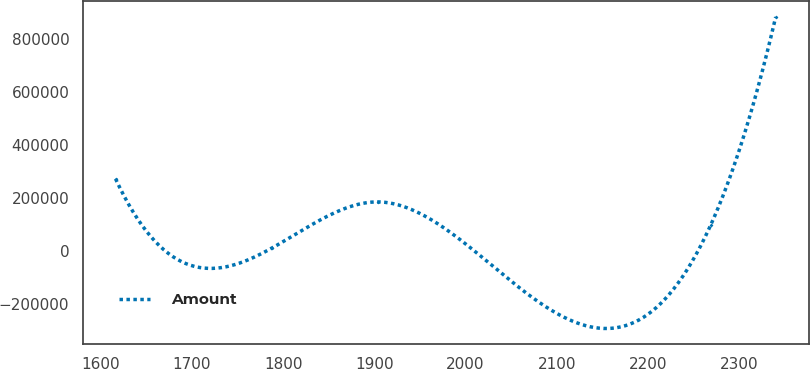Convert chart to OTSL. <chart><loc_0><loc_0><loc_500><loc_500><line_chart><ecel><fcel>Amount<nl><fcel>1616.24<fcel>272656<nl><fcel>1787.55<fcel>11758.5<nl><fcel>1903.82<fcel>185690<nl><fcel>2268.88<fcel>98724.5<nl><fcel>2340.12<fcel>881418<nl></chart> 